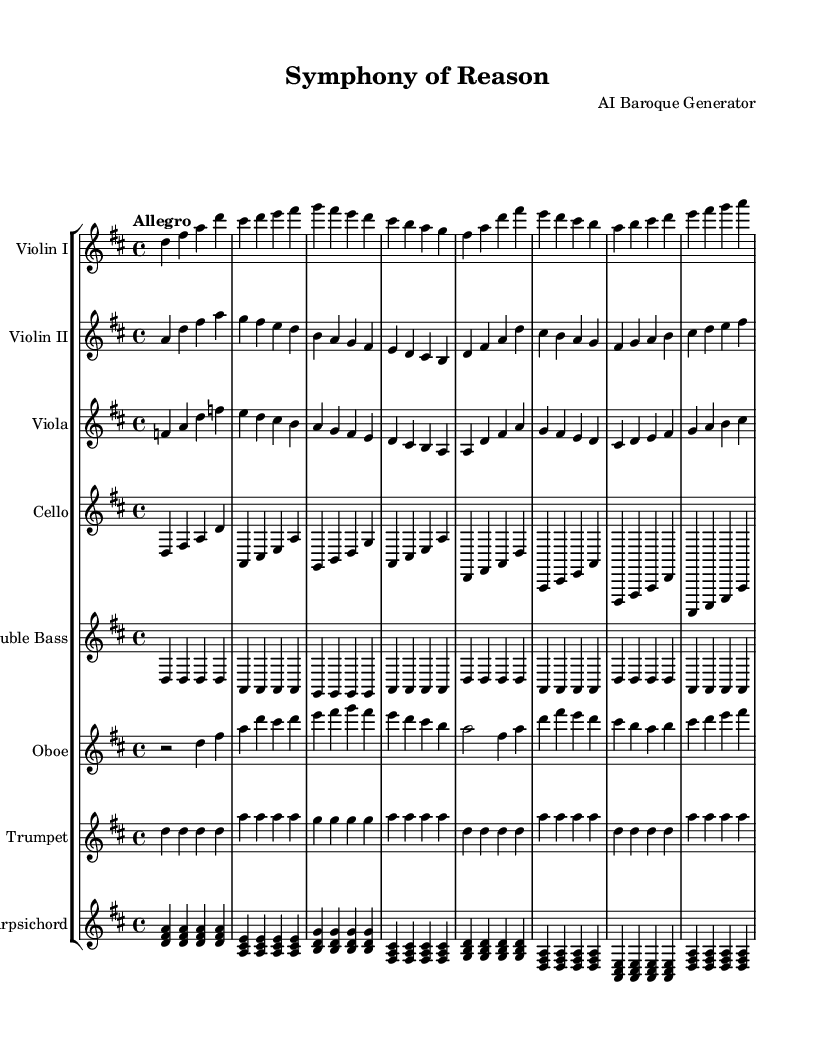What is the key signature of this music? The key signature indicates two sharps, which corresponds to the key of D major. This is determined by observing the key signature section of the sheet music.
Answer: D major What is the time signature of this music? The time signature is found at the beginning of the sheet music, shown as 4/4. This means there are four beats in each measure, and the quarter note gets one beat.
Answer: 4/4 What is the tempo marking for this music? The tempo marking 'Allegro' is indicated at the beginning, which suggests a fast and lively pace. It can be observed at the start of the sheet music above the staff.
Answer: Allegro How many instruments are in the orchestration? There are eight distinct instruments listed in the orchestration, which can be counted from the staff group section where each instrument is labeled.
Answer: Eight Which instrument has the highest pitch range in this piece? The violin I instrument typically plays in the highest pitch range. You can determine this by comparing the written notes on the staff for each instrument; violin I has the highest notes overall in the score.
Answer: Violin I What is the role of the harpsichord in this composition? The harpsichord acts as a continuo and harmonic support in the piece, accompanying the melodies of the strings and woodwinds. This can be deduced from its rhythmical presence throughout the music, contributing to the harmonic texture.
Answer: Continuo What characteristic of Baroque music is demonstrated by the use of instrumental sections? The use of contrasting instrumental sections in a concerto-like fashion, displaying the Baroque affinity for a dialogue between various instrument groups, shows this characteristic. This reflects the stylistic features often found in Baroque orchestral works.
Answer: Contrast 